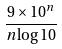<formula> <loc_0><loc_0><loc_500><loc_500>\frac { 9 \times 1 0 ^ { n } } { n \log 1 0 }</formula> 